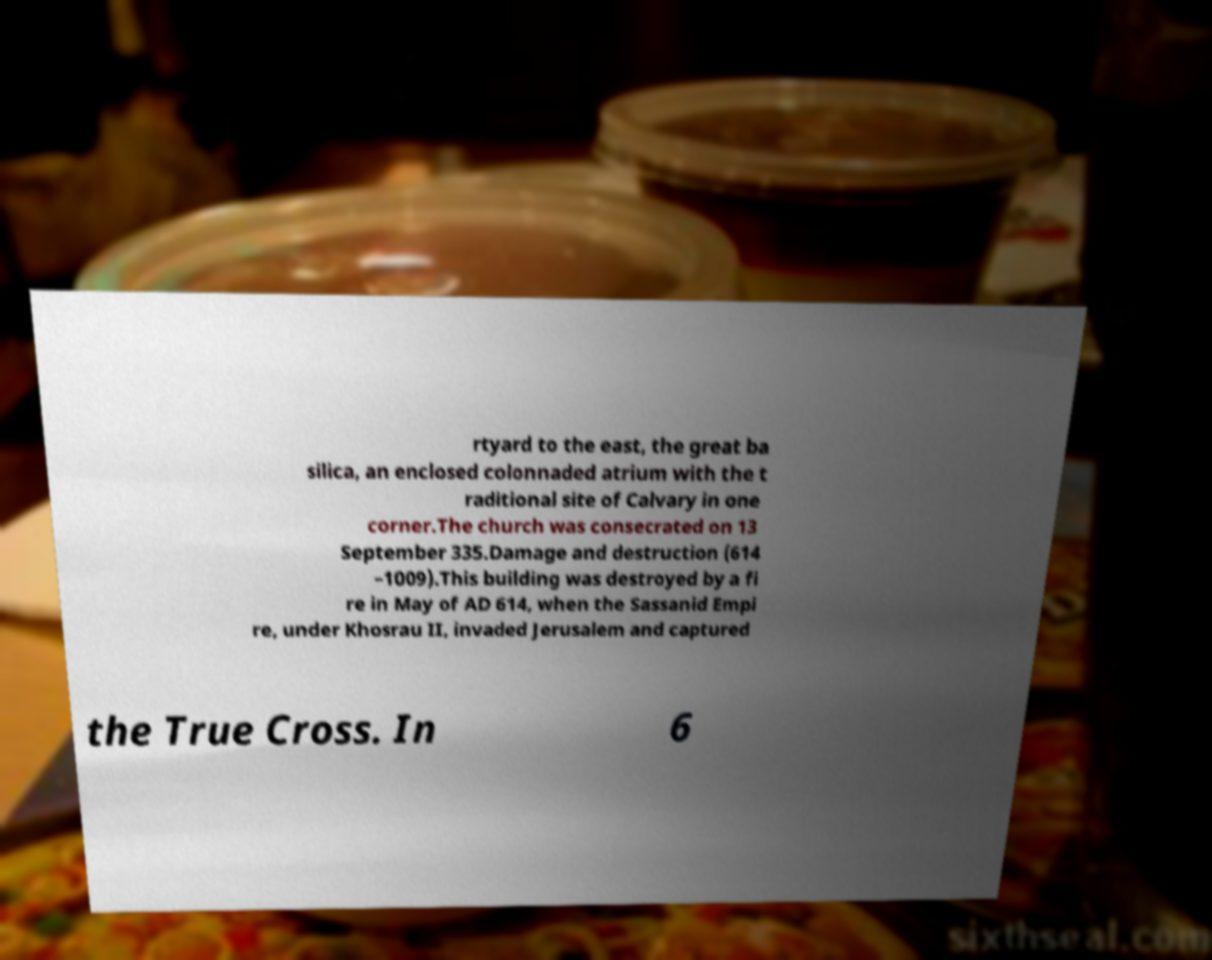There's text embedded in this image that I need extracted. Can you transcribe it verbatim? rtyard to the east, the great ba silica, an enclosed colonnaded atrium with the t raditional site of Calvary in one corner.The church was consecrated on 13 September 335.Damage and destruction (614 –1009).This building was destroyed by a fi re in May of AD 614, when the Sassanid Empi re, under Khosrau II, invaded Jerusalem and captured the True Cross. In 6 